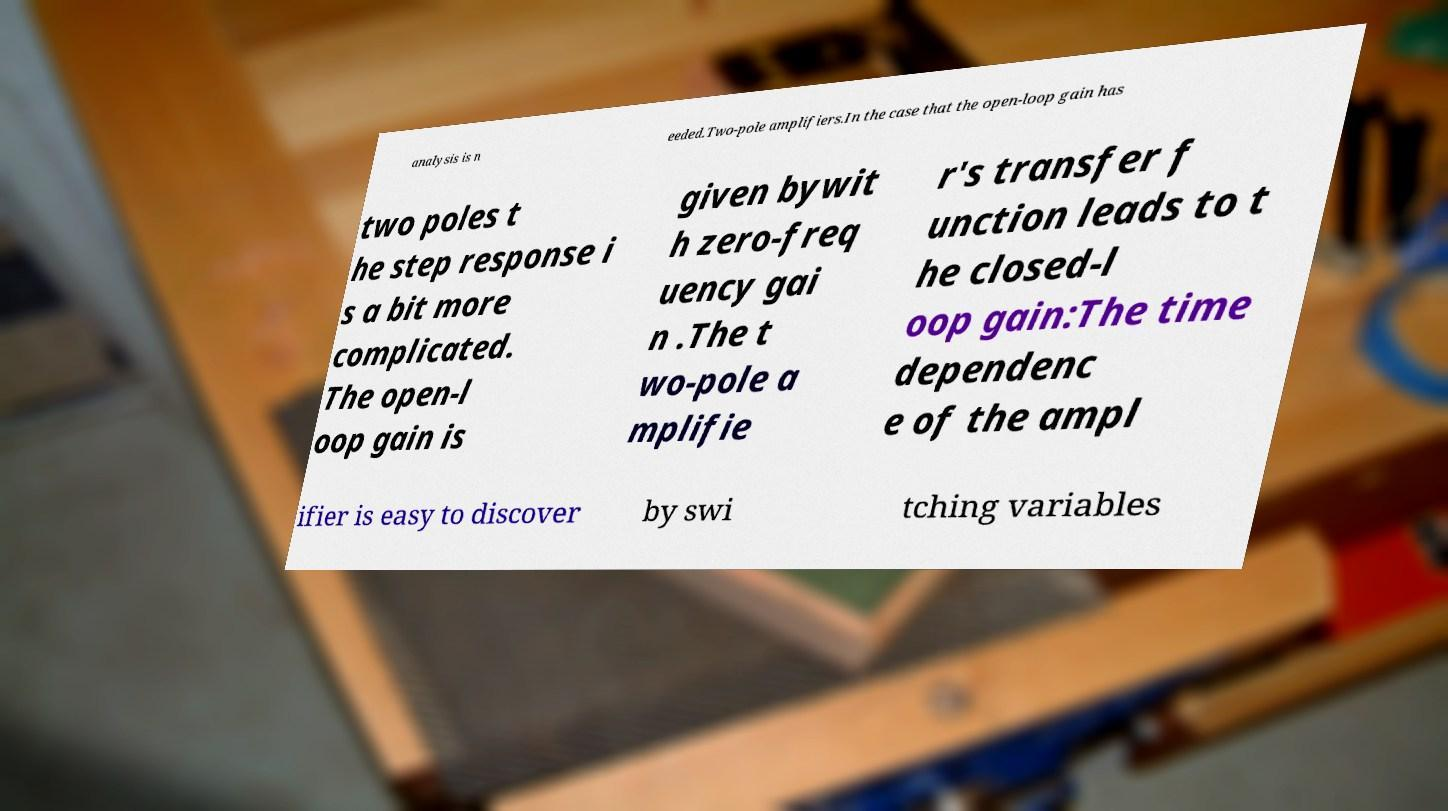What messages or text are displayed in this image? I need them in a readable, typed format. analysis is n eeded.Two-pole amplifiers.In the case that the open-loop gain has two poles t he step response i s a bit more complicated. The open-l oop gain is given bywit h zero-freq uency gai n .The t wo-pole a mplifie r's transfer f unction leads to t he closed-l oop gain:The time dependenc e of the ampl ifier is easy to discover by swi tching variables 